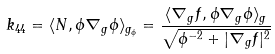Convert formula to latex. <formula><loc_0><loc_0><loc_500><loc_500>k _ { 4 4 } = \langle N , \phi \nabla _ { g } \phi \rangle _ { g _ { \phi } } = \frac { \langle \nabla _ { g } f , \phi \nabla _ { g } \phi \rangle _ { g } } { \sqrt { \phi ^ { - 2 } + | \nabla _ { g } f | ^ { 2 } } }</formula> 